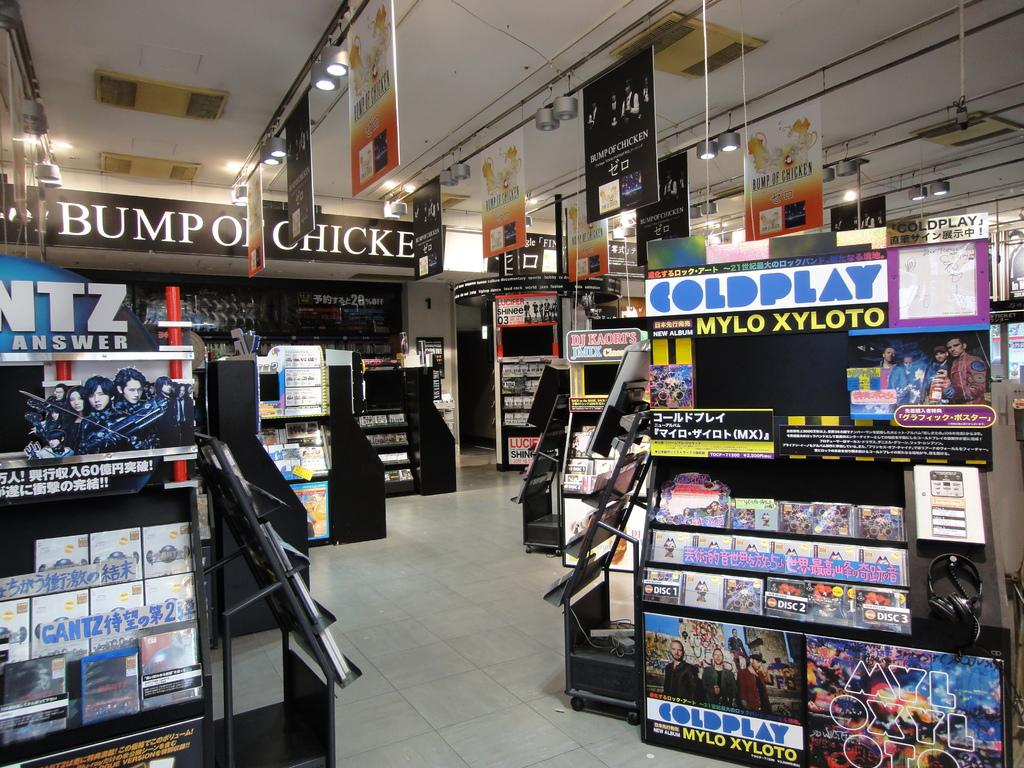<image>
Offer a succinct explanation of the picture presented. Many displays including Coldplay, Bump of Chicken and DJ Kaorts. 